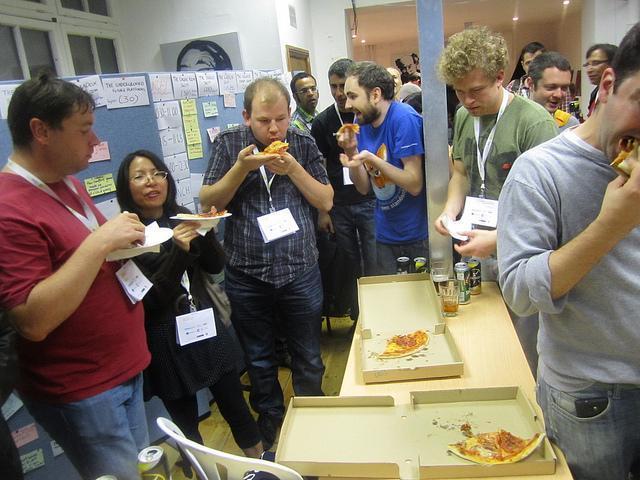How many people can be seen?
Give a very brief answer. 8. How many pizzas can be seen?
Give a very brief answer. 1. How many oranges can be seen?
Give a very brief answer. 0. 